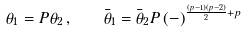Convert formula to latex. <formula><loc_0><loc_0><loc_500><loc_500>\theta _ { 1 } = P \theta _ { 2 } \, , \quad \bar { \theta } _ { 1 } = \bar { \theta } _ { 2 } P \, ( - ) ^ { \frac { ( p - 1 ) ( p - 2 ) } { 2 } + p }</formula> 